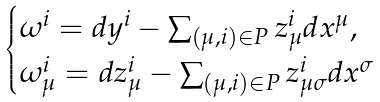<formula> <loc_0><loc_0><loc_500><loc_500>\begin{cases} \omega ^ { i } = d y ^ { i } - \sum _ { ( \mu , i ) \in P } z ^ { i } _ { \mu } d x ^ { \mu } , \\ \omega ^ { i } _ { \mu } = d z ^ { i } _ { \mu } - \sum _ { ( \mu , i ) \in P } z ^ { i } _ { \mu \sigma } d x ^ { \sigma } \end{cases}</formula> 